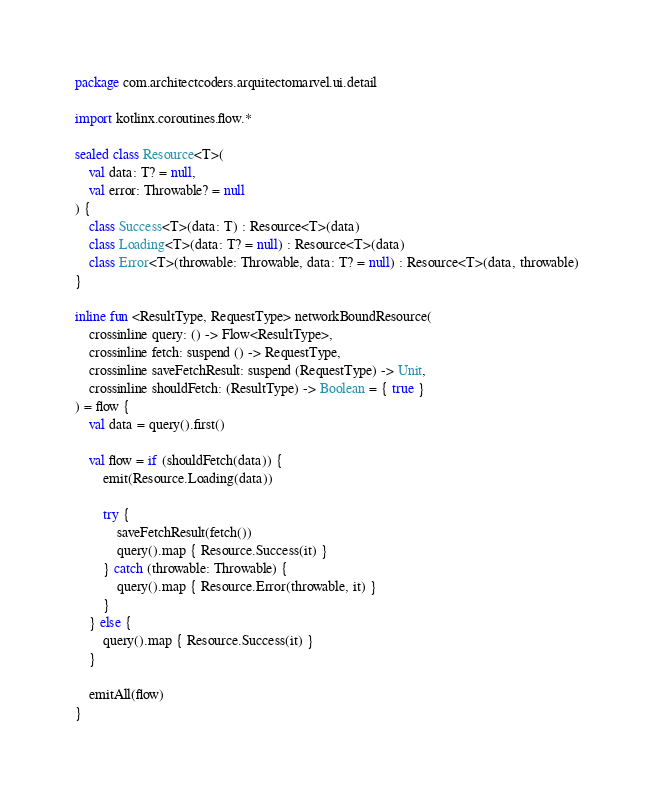Convert code to text. <code><loc_0><loc_0><loc_500><loc_500><_Kotlin_>package com.architectcoders.arquitectomarvel.ui.detail

import kotlinx.coroutines.flow.*

sealed class Resource<T>(
    val data: T? = null,
    val error: Throwable? = null
) {
    class Success<T>(data: T) : Resource<T>(data)
    class Loading<T>(data: T? = null) : Resource<T>(data)
    class Error<T>(throwable: Throwable, data: T? = null) : Resource<T>(data, throwable)
}

inline fun <ResultType, RequestType> networkBoundResource(
    crossinline query: () -> Flow<ResultType>,
    crossinline fetch: suspend () -> RequestType,
    crossinline saveFetchResult: suspend (RequestType) -> Unit,
    crossinline shouldFetch: (ResultType) -> Boolean = { true }
) = flow {
    val data = query().first()

    val flow = if (shouldFetch(data)) {
        emit(Resource.Loading(data))

        try {
            saveFetchResult(fetch())
            query().map { Resource.Success(it) }
        } catch (throwable: Throwable) {
            query().map { Resource.Error(throwable, it) }
        }
    } else {
        query().map { Resource.Success(it) }
    }

    emitAll(flow)
}
</code> 